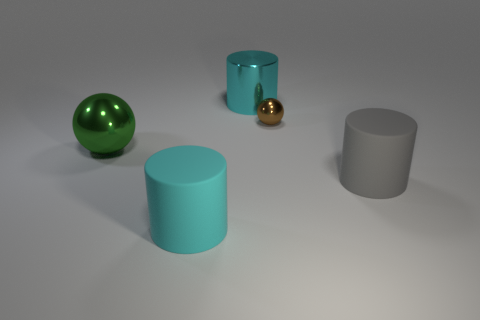Could these objects be part of a larger set or collection? It's quite possible that these objects are part of a larger set, designed to represent an array of geometric shapes and surface materials. They may also be exemplary pieces from a collection that focuses on demonstrating the reflective and textural properties of various materials under similar lighting conditions. 